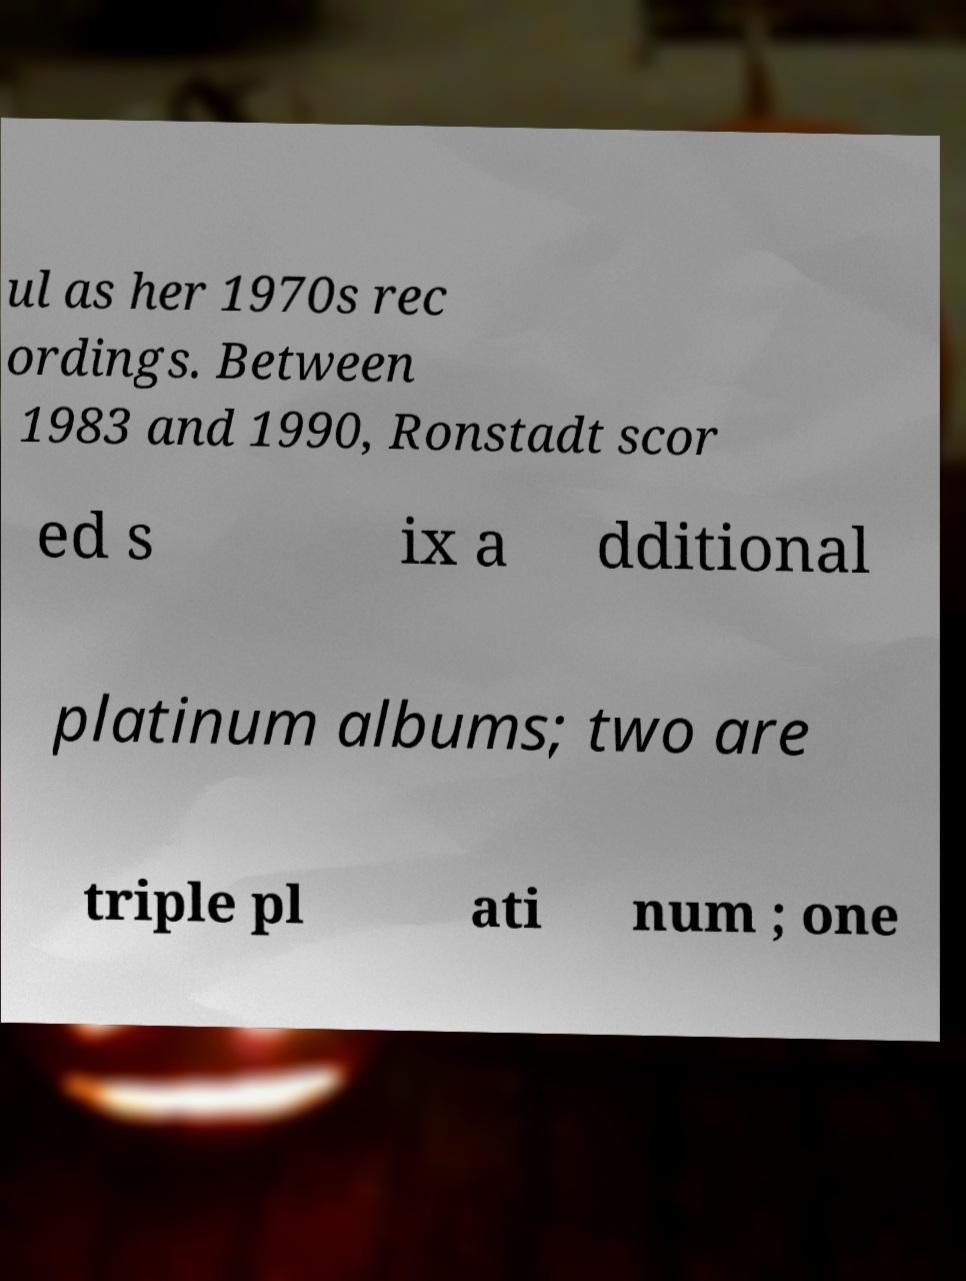Could you extract and type out the text from this image? ul as her 1970s rec ordings. Between 1983 and 1990, Ronstadt scor ed s ix a dditional platinum albums; two are triple pl ati num ; one 